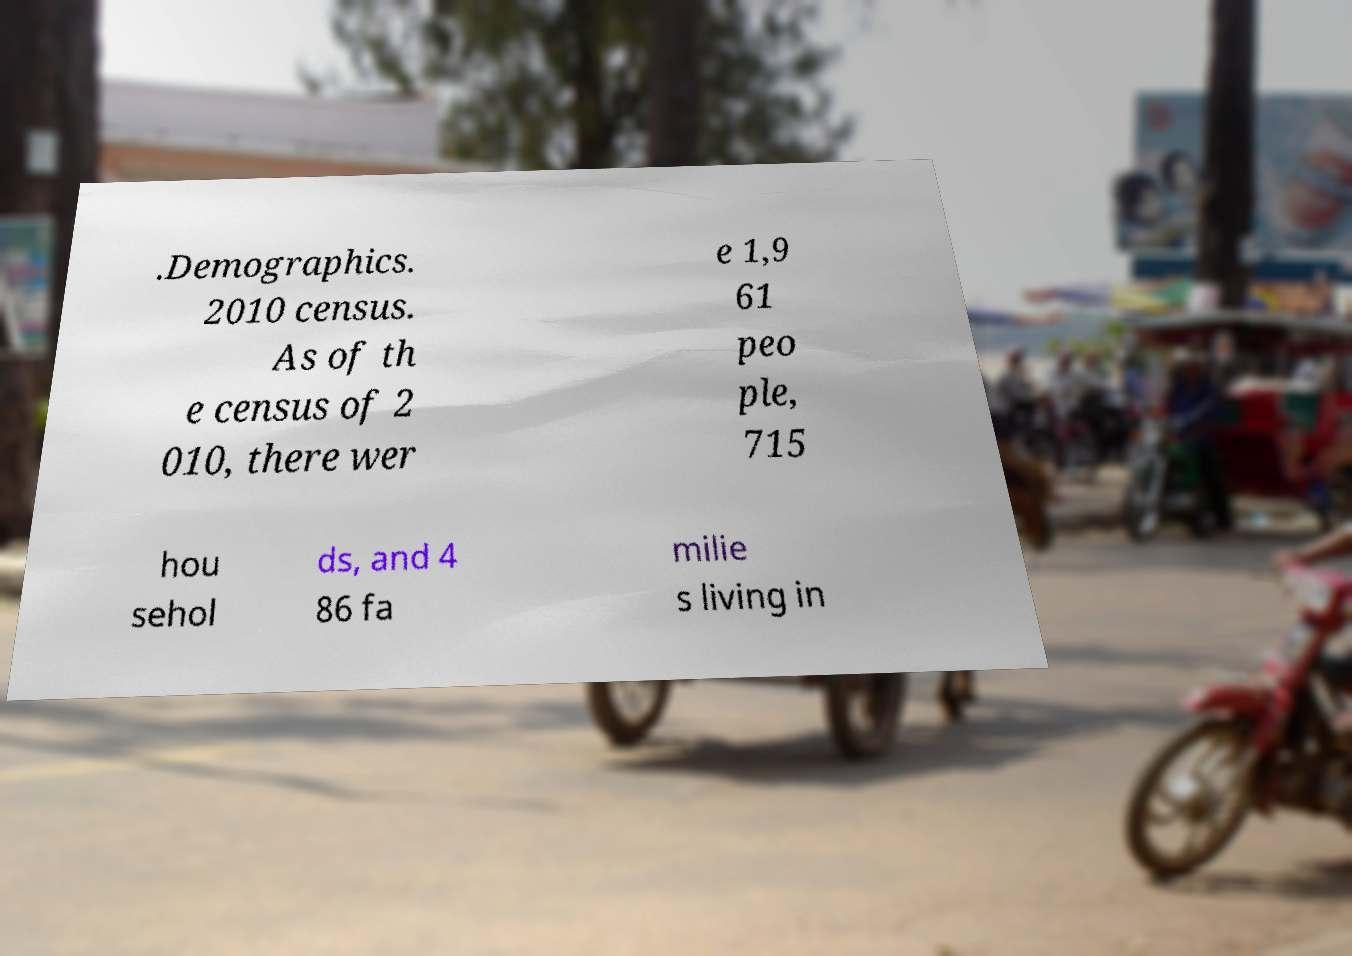Please read and relay the text visible in this image. What does it say? .Demographics. 2010 census. As of th e census of 2 010, there wer e 1,9 61 peo ple, 715 hou sehol ds, and 4 86 fa milie s living in 